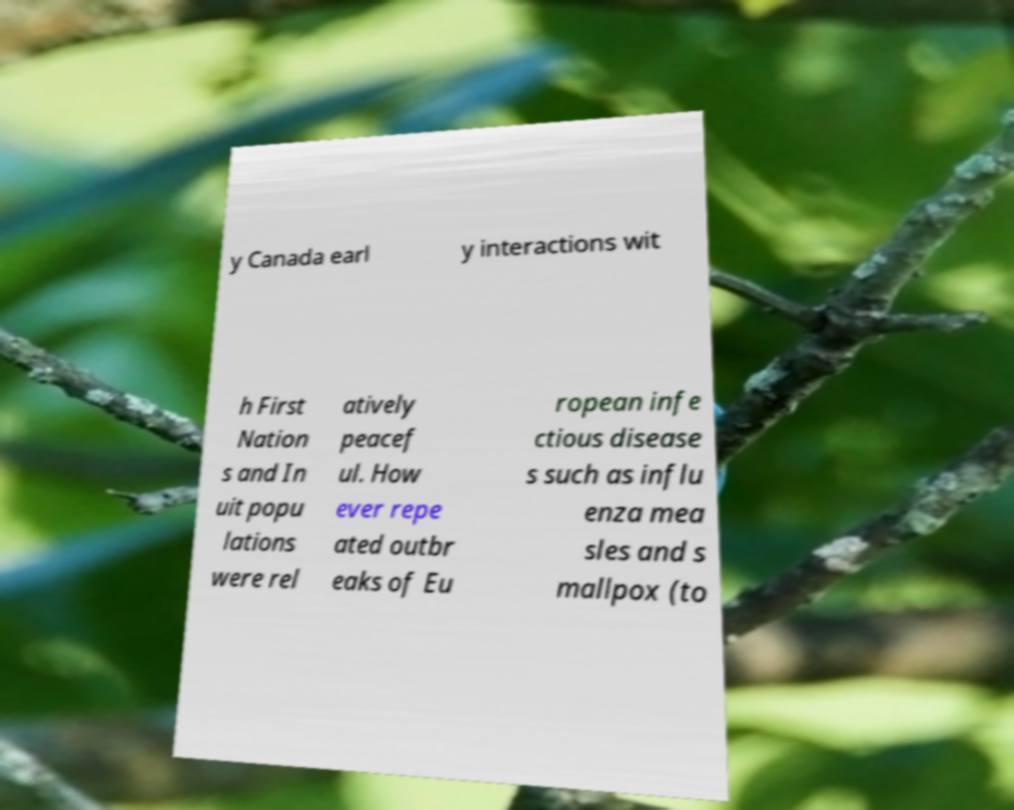Please identify and transcribe the text found in this image. y Canada earl y interactions wit h First Nation s and In uit popu lations were rel atively peacef ul. How ever repe ated outbr eaks of Eu ropean infe ctious disease s such as influ enza mea sles and s mallpox (to 